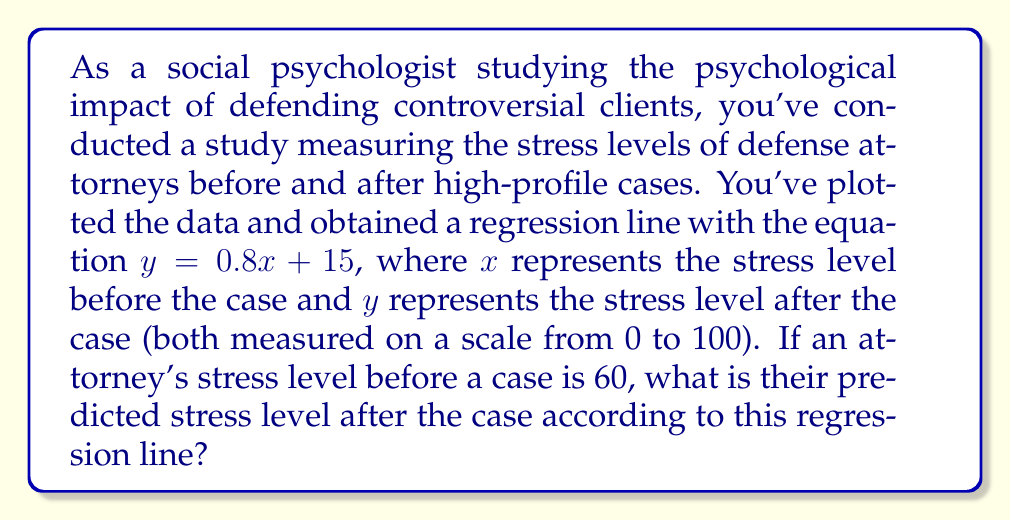What is the answer to this math problem? To solve this problem, we need to use the given regression equation and substitute the known value for $x$. Let's break it down step-by-step:

1. The regression equation is given as:
   $y = 0.8x + 15$

2. We're told that the attorney's stress level before the case ($x$) is 60.

3. To find the predicted stress level after the case ($y$), we substitute $x = 60$ into the equation:

   $y = 0.8(60) + 15$

4. Now, let's calculate:
   $y = 48 + 15$

5. Simplifying:
   $y = 63$

This result indicates that for an attorney with a pre-case stress level of 60, the model predicts a post-case stress level of 63.

Interpreting this result in the context of the study:
- The positive slope (0.8) indicates that higher pre-case stress levels generally correspond to higher post-case stress levels.
- The increase from 60 to 63 suggests that defending controversial clients tends to slightly increase stress levels.
- The y-intercept of 15 implies that even with no pre-case stress (which is unlikely in reality), there would still be some baseline post-case stress.
Answer: The predicted stress level after the case is 63. 